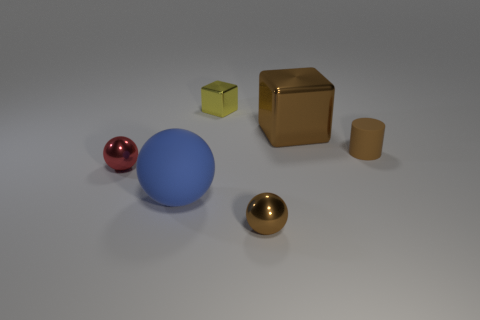Add 3 tiny blocks. How many objects exist? 9 Subtract all cubes. How many objects are left? 4 Add 3 big blue rubber things. How many big blue rubber things exist? 4 Subtract 0 green cubes. How many objects are left? 6 Subtract all purple shiny cubes. Subtract all small red metallic objects. How many objects are left? 5 Add 4 brown rubber objects. How many brown rubber objects are left? 5 